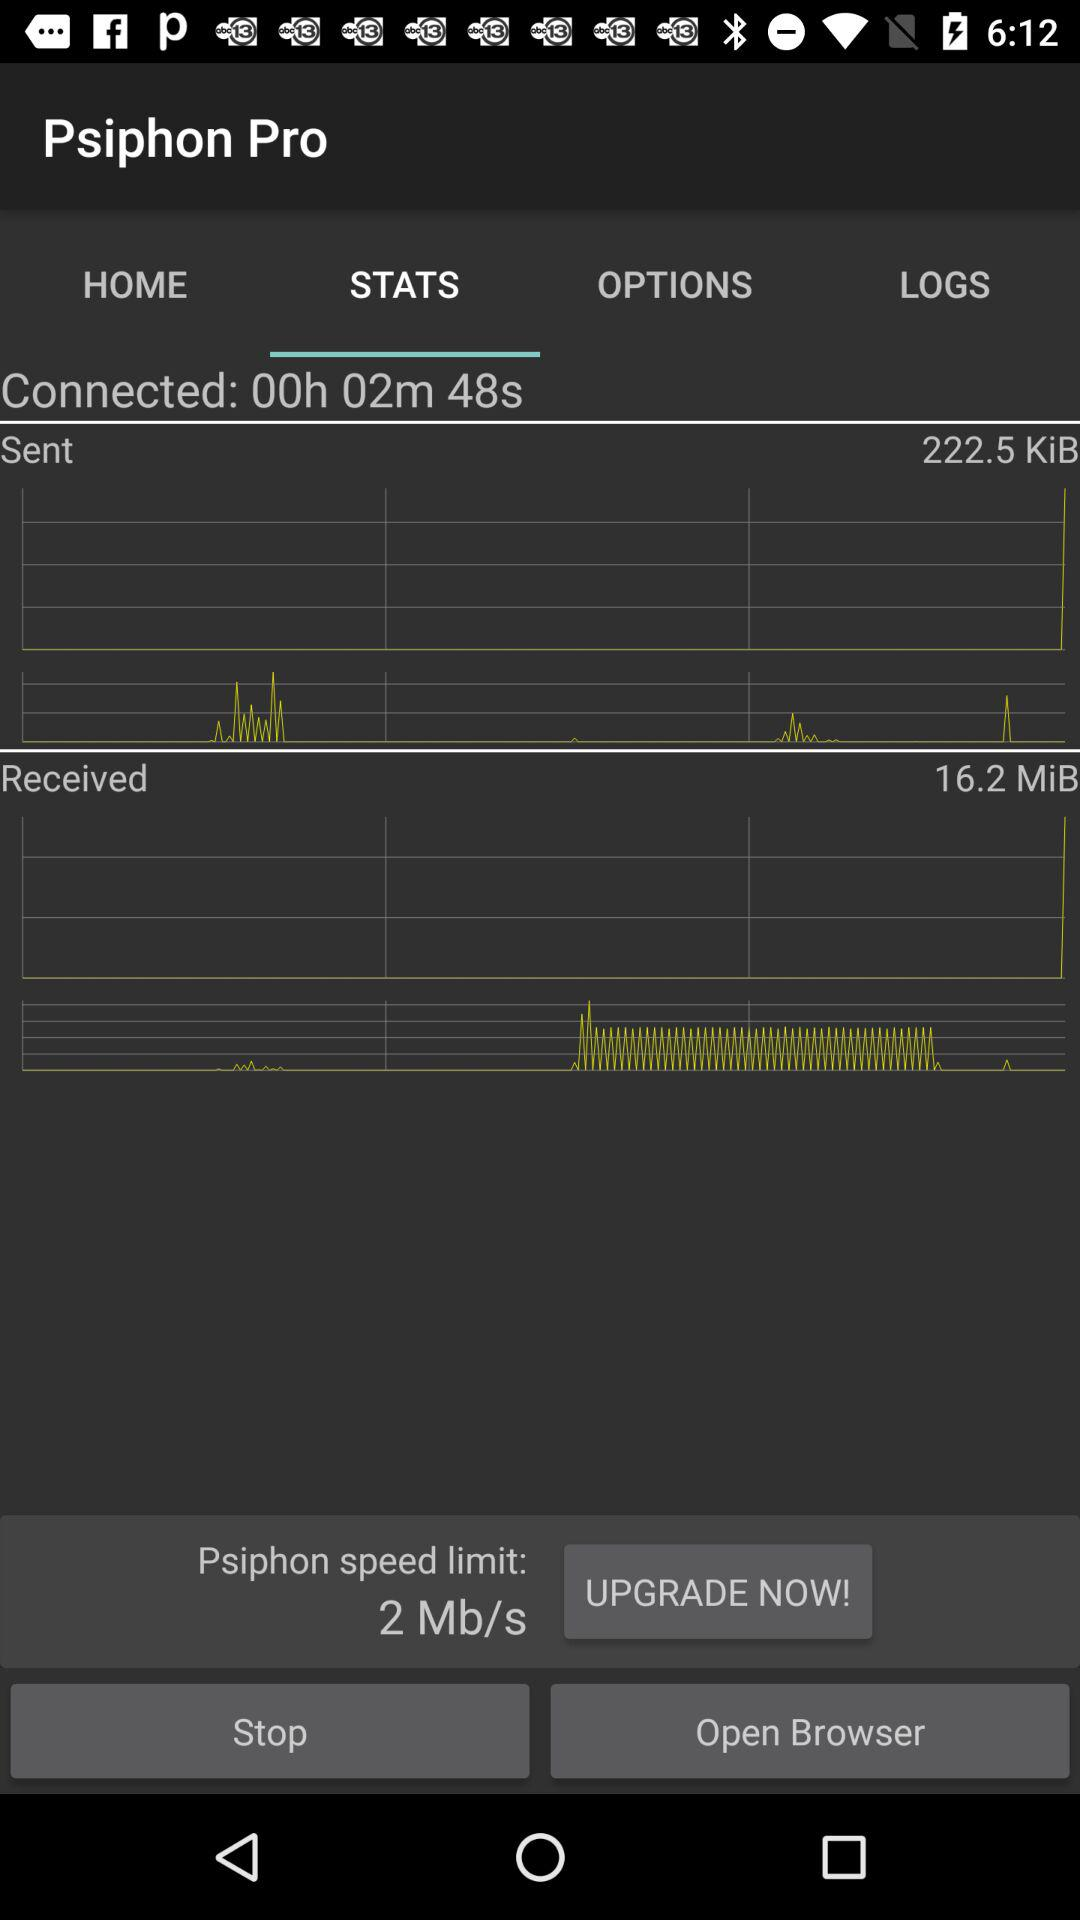Which option is selected? The selected option is "STATS". 